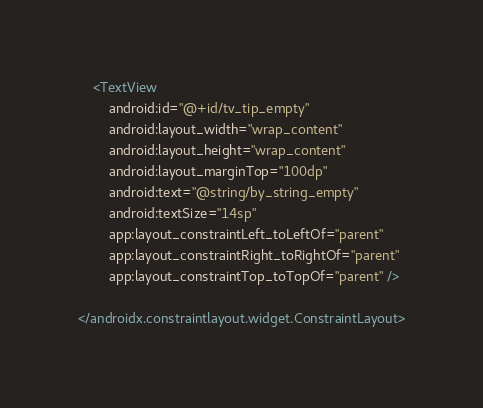<code> <loc_0><loc_0><loc_500><loc_500><_XML_>    <TextView
        android:id="@+id/tv_tip_empty"
        android:layout_width="wrap_content"
        android:layout_height="wrap_content"
        android:layout_marginTop="100dp"
        android:text="@string/by_string_empty"
        android:textSize="14sp"
        app:layout_constraintLeft_toLeftOf="parent"
        app:layout_constraintRight_toRightOf="parent"
        app:layout_constraintTop_toTopOf="parent" />

</androidx.constraintlayout.widget.ConstraintLayout>
</code> 